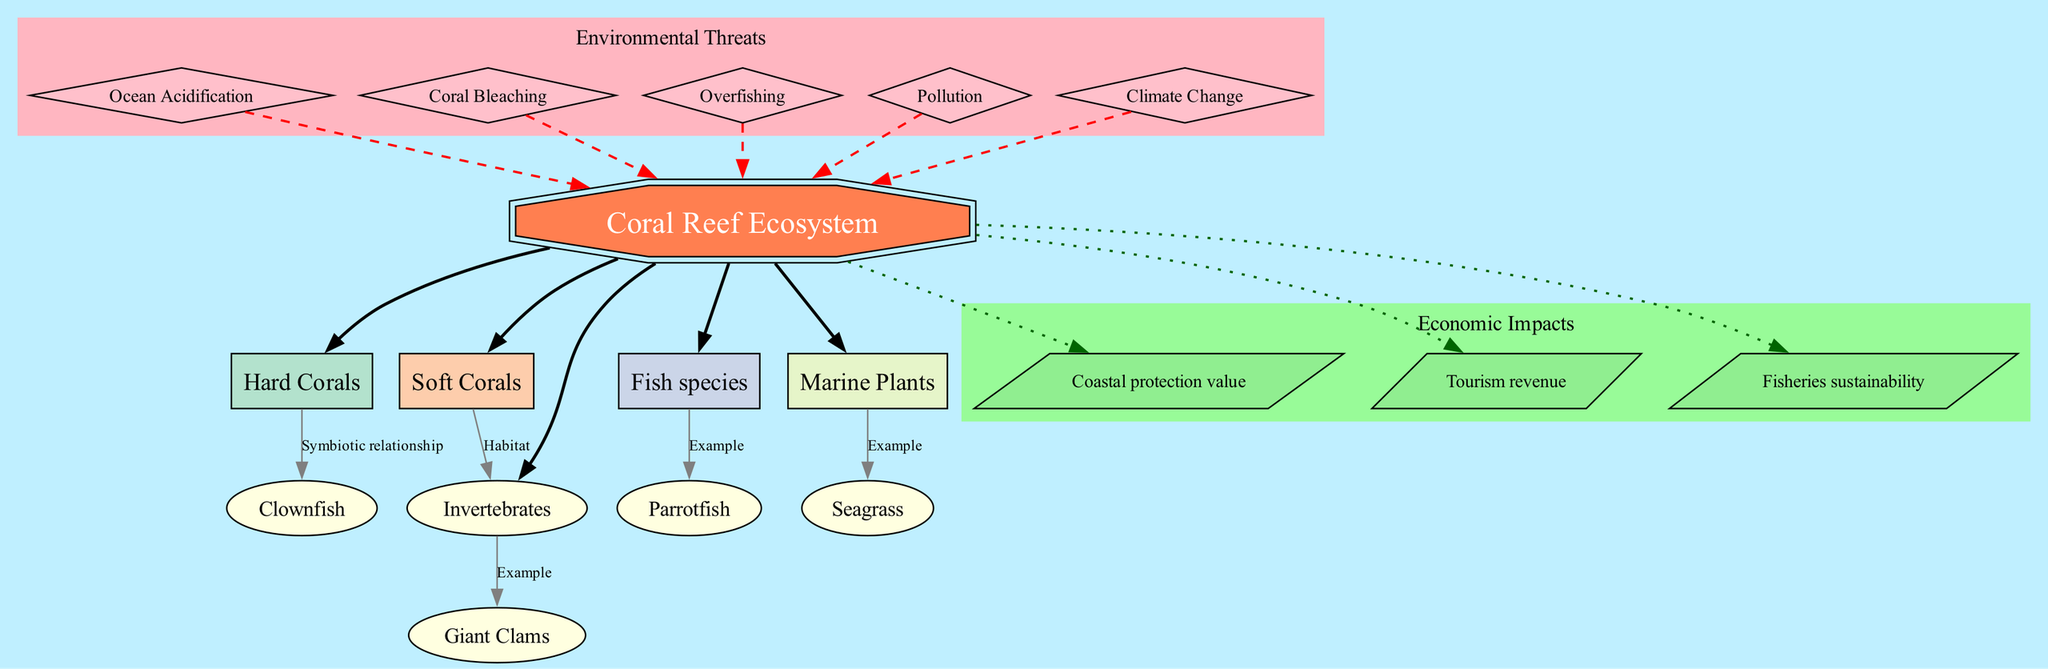What is the central node in this diagram? The central node of the diagram is indicated clearly and labeled at the top of the structure, which is the "Coral Reef Ecosystem."
Answer: Coral Reef Ecosystem How many primary nodes are there? By counting the names listed under the primary nodes section, there are five nodes: Hard Corals, Soft Corals, Fish species, Invertebrates, and Marine Plants.
Answer: 5 What type of relationship exists between Hard Corals and Clownfish? The diagram explicitly states the connection between Hard Corals and Clownfish as a "Symbiotic relationship," connecting these two nodes directly.
Answer: Symbiotic relationship Which environmental threat is associated with the coral reef ecosystem? The diagram lists several environmental threats, with examples including "Ocean Acidification," "Coral Bleaching," "Overfishing," and others that link back to the central node.
Answer: Ocean Acidification What is a secondary node example of Fish species? In the connections section, the Fish species are associated specifically with the "Parrotfish," indicating it as a representative example.
Answer: Parrotfish How are economic impacts shown in the diagram? The diagram contains a distinct section labeled as "Economic Impacts," wherein various economic benefits related to the ecosystem are highlighted, such as tourism revenue and fisheries sustainability.
Answer: Tourism revenue Which environmental threat has a dashed line connecting to the central node? The dashed lines are utilized to connect the environmental threats to the central node, clearly indicating the negative influences on the ecosystem, starting with "Ocean Acidification" as the first example listed.
Answer: Ocean Acidification How many economic impacts are listed in the diagram? The economic impacts section of the diagram lists three distinct impacts: Tourism revenue, Fisheries sustainability, and Coastal protection value, confirming the count.
Answer: 3 What does the node labeled "Giant Clams" represent? "Giant Clams" is positioned under the Invertebrates in the connections section, indicating it as an example of the diverse life forms that inhabit coral reefs and their role in the ecosystem.
Answer: Example 